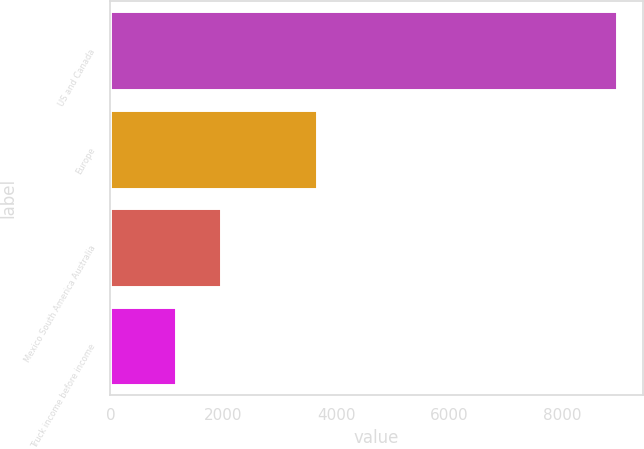<chart> <loc_0><loc_0><loc_500><loc_500><bar_chart><fcel>US and Canada<fcel>Europe<fcel>Mexico South America Australia<fcel>Truck income before income<nl><fcel>8974.5<fcel>3657.6<fcel>1961.9<fcel>1160.1<nl></chart> 